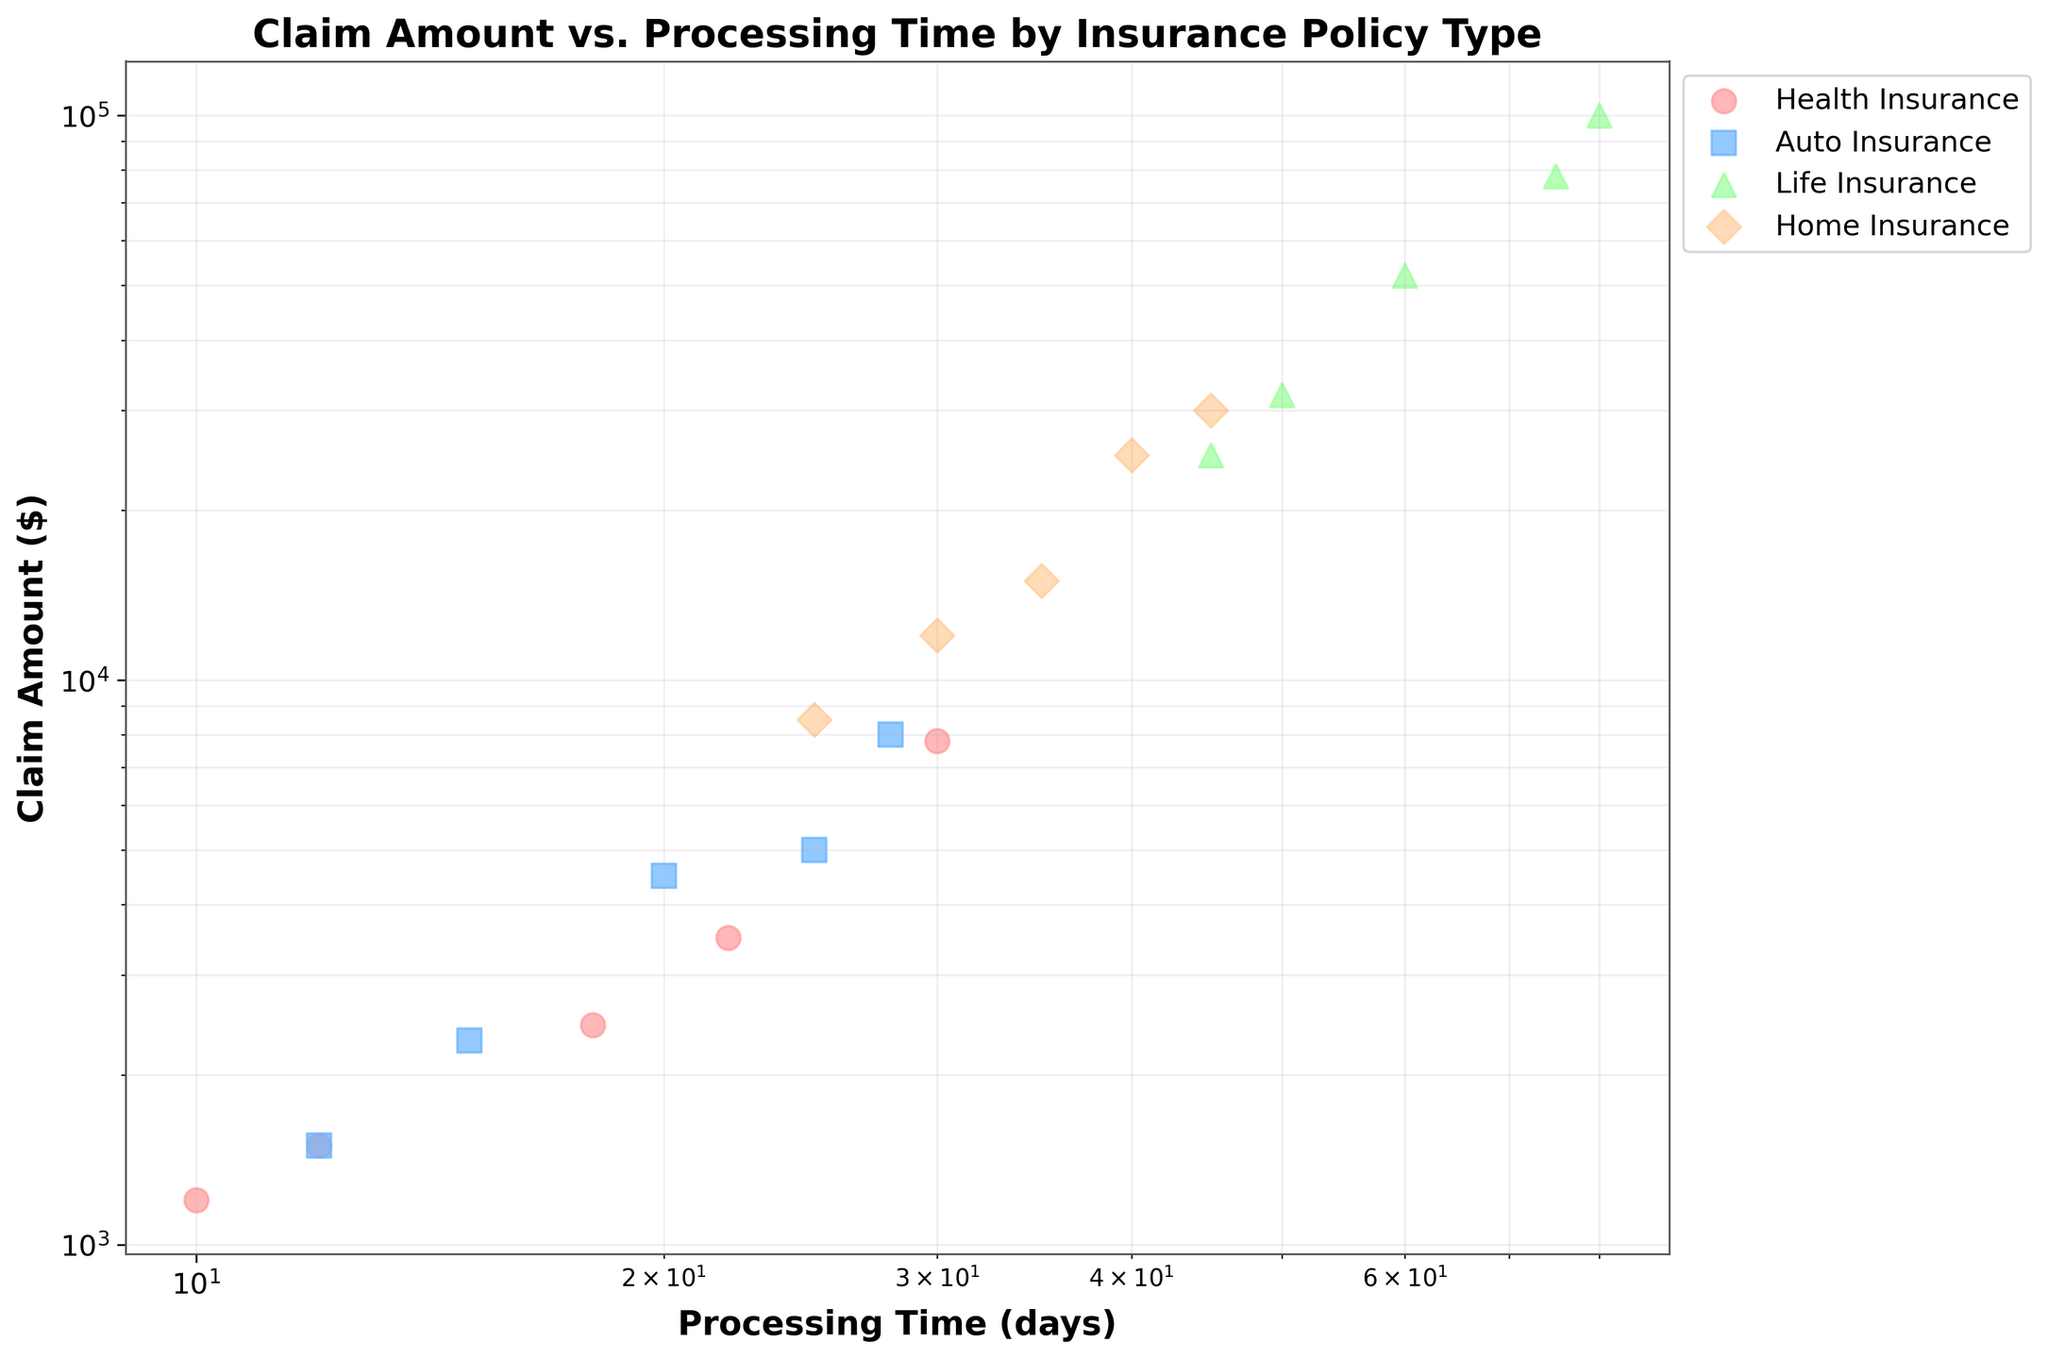What is the title of the figure? The title of the figure is written at the top of the chart. It serves to provide a brief description of what the figure represents.
Answer: Claim Amount vs. Processing Time by Insurance Policy Type Which axis represents the Claim Amount? By looking at the labels provided on the axes, the axis that shows 'Claim Amount ($)' is the one representing the claim amounts.
Answer: Y-axis What colors represent different policy types in the scatter plot? The scatter plot uses distinct colors for different policy types. By referring to the legend, one can determine the colors assigned to Health Insurance, Auto Insurance, Life Insurance, and Home Insurance.
Answer: Health Insurance: Red, Auto Insurance: Blue, Life Insurance: Green, Home Insurance: Orange What is the range of Processing Time for Health Insurance claims? The range for Health Insurance claims can be identified by looking at the x-axis positions of the red markers (circles) in the scatter plot. Identify their minimum and maximum values.
Answer: 10 - 30 days Which policy type has the highest Claim Amount value? Identify which group has data points plotted the highest on the y-axis. The legend can then be used to determine the corresponding policy type.
Answer: Life Insurance How does the Claim Amount for Auto Insurance compare to Home Insurance within the same processing time range? Observe the spread of data points (claim amounts) for both Auto Insurance and Home Insurance along the same range of x-axis values (processing times). Compare their general y-axis positions.
Answer: Auto Insurance generally has higher Claim Amounts than Home Insurance within the same processing time range What is the average Processing Time for Life Insurance claims? Look at the x-axis positions for green markers (triangles), add these values together, and then divide by the number of data points (5 in this case). (50 + 45 + 60 + 75 + 80 = 310) / 5.
Answer: 62 days Which type of insurance policy has data points most concentrated around Processing Time of 30 days? Identify which policy type has the majority of its data points clustered near the x-axis value of 30 days.
Answer: Home Insurance How does the Processing Time tend to affect the Claim Amount across different policy types? By observing the overall trends of data points for each policy type, infer if there is a general increase or decrease in claim amounts with processing time. Notice that while variations exist, some types may increase or remain stable.
Answer: Processing Time generally increases with Claim Amount, except for Health Insurance Which policy type shows the most variation in Claim Amounts? By observing the spread and range of claim amounts on the y-axis for each policy type, determine which has the widest distribution of values.
Answer: Life Insurance 